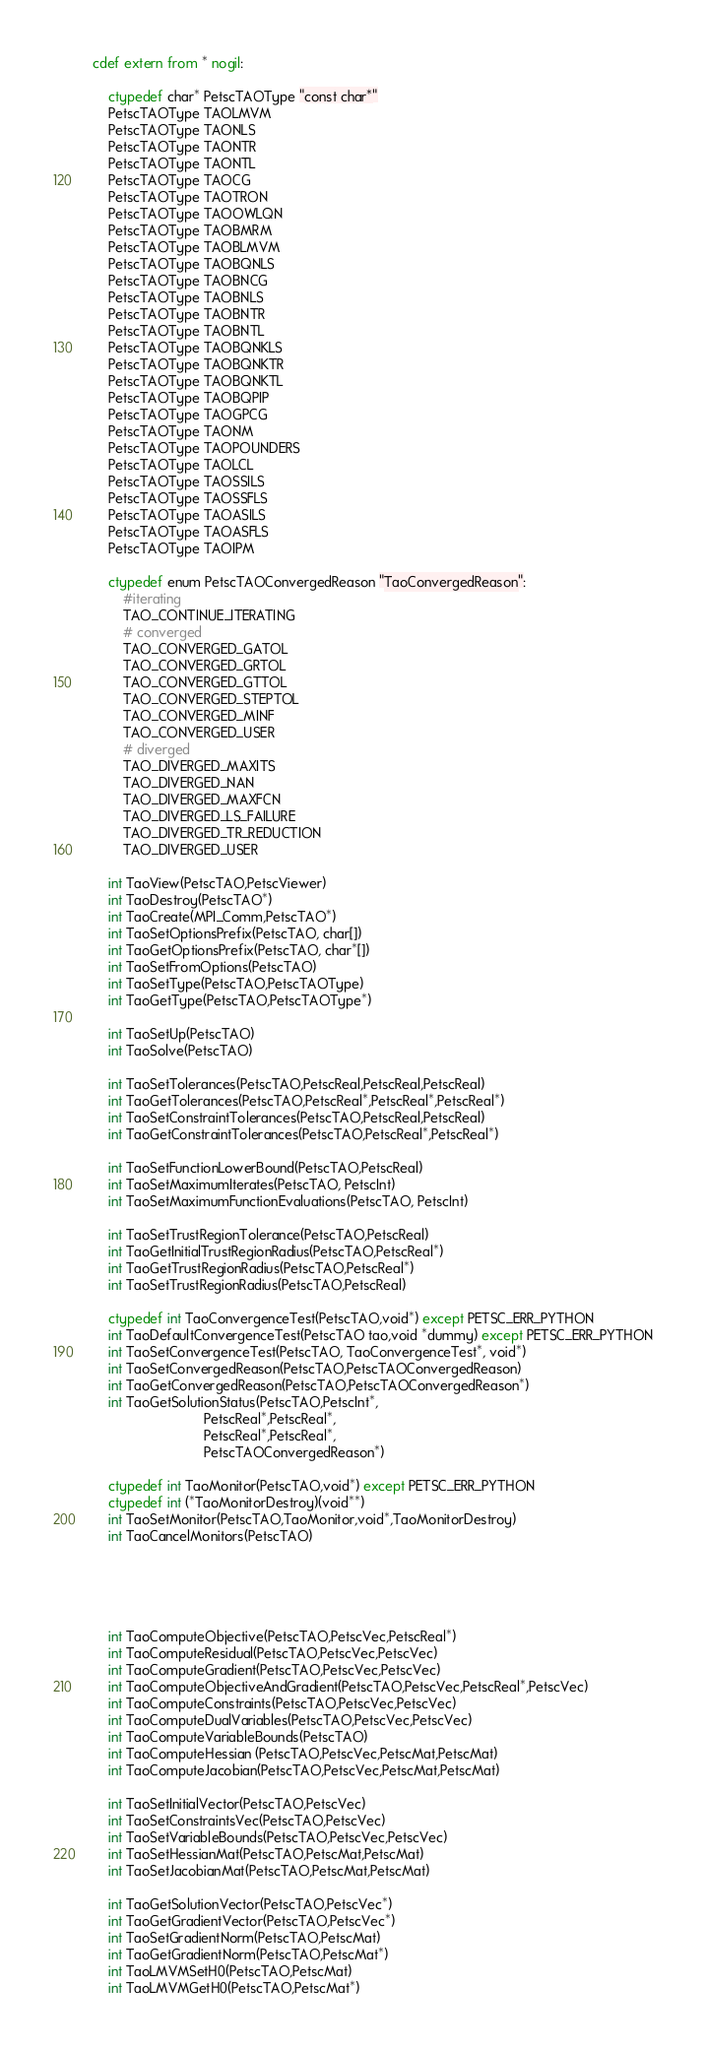<code> <loc_0><loc_0><loc_500><loc_500><_Cython_>cdef extern from * nogil:

    ctypedef char* PetscTAOType "const char*"
    PetscTAOType TAOLMVM
    PetscTAOType TAONLS
    PetscTAOType TAONTR
    PetscTAOType TAONTL
    PetscTAOType TAOCG
    PetscTAOType TAOTRON
    PetscTAOType TAOOWLQN
    PetscTAOType TAOBMRM
    PetscTAOType TAOBLMVM
    PetscTAOType TAOBQNLS
    PetscTAOType TAOBNCG
    PetscTAOType TAOBNLS
    PetscTAOType TAOBNTR
    PetscTAOType TAOBNTL
    PetscTAOType TAOBQNKLS
    PetscTAOType TAOBQNKTR
    PetscTAOType TAOBQNKTL
    PetscTAOType TAOBQPIP
    PetscTAOType TAOGPCG
    PetscTAOType TAONM
    PetscTAOType TAOPOUNDERS
    PetscTAOType TAOLCL
    PetscTAOType TAOSSILS
    PetscTAOType TAOSSFLS
    PetscTAOType TAOASILS
    PetscTAOType TAOASFLS
    PetscTAOType TAOIPM

    ctypedef enum PetscTAOConvergedReason "TaoConvergedReason":
        #iterating
        TAO_CONTINUE_ITERATING
        # converged
        TAO_CONVERGED_GATOL
        TAO_CONVERGED_GRTOL
        TAO_CONVERGED_GTTOL
        TAO_CONVERGED_STEPTOL
        TAO_CONVERGED_MINF
        TAO_CONVERGED_USER
        # diverged
        TAO_DIVERGED_MAXITS
        TAO_DIVERGED_NAN
        TAO_DIVERGED_MAXFCN
        TAO_DIVERGED_LS_FAILURE
        TAO_DIVERGED_TR_REDUCTION
        TAO_DIVERGED_USER

    int TaoView(PetscTAO,PetscViewer)
    int TaoDestroy(PetscTAO*)
    int TaoCreate(MPI_Comm,PetscTAO*)
    int TaoSetOptionsPrefix(PetscTAO, char[])
    int TaoGetOptionsPrefix(PetscTAO, char*[])
    int TaoSetFromOptions(PetscTAO)
    int TaoSetType(PetscTAO,PetscTAOType)
    int TaoGetType(PetscTAO,PetscTAOType*)

    int TaoSetUp(PetscTAO)
    int TaoSolve(PetscTAO)

    int TaoSetTolerances(PetscTAO,PetscReal,PetscReal,PetscReal)
    int TaoGetTolerances(PetscTAO,PetscReal*,PetscReal*,PetscReal*)
    int TaoSetConstraintTolerances(PetscTAO,PetscReal,PetscReal)
    int TaoGetConstraintTolerances(PetscTAO,PetscReal*,PetscReal*)

    int TaoSetFunctionLowerBound(PetscTAO,PetscReal)
    int TaoSetMaximumIterates(PetscTAO, PetscInt)
    int TaoSetMaximumFunctionEvaluations(PetscTAO, PetscInt)

    int TaoSetTrustRegionTolerance(PetscTAO,PetscReal)
    int TaoGetInitialTrustRegionRadius(PetscTAO,PetscReal*)
    int TaoGetTrustRegionRadius(PetscTAO,PetscReal*)
    int TaoSetTrustRegionRadius(PetscTAO,PetscReal)

    ctypedef int TaoConvergenceTest(PetscTAO,void*) except PETSC_ERR_PYTHON
    int TaoDefaultConvergenceTest(PetscTAO tao,void *dummy) except PETSC_ERR_PYTHON
    int TaoSetConvergenceTest(PetscTAO, TaoConvergenceTest*, void*)
    int TaoSetConvergedReason(PetscTAO,PetscTAOConvergedReason)
    int TaoGetConvergedReason(PetscTAO,PetscTAOConvergedReason*)
    int TaoGetSolutionStatus(PetscTAO,PetscInt*,
                             PetscReal*,PetscReal*,
                             PetscReal*,PetscReal*,
                             PetscTAOConvergedReason*)

    ctypedef int TaoMonitor(PetscTAO,void*) except PETSC_ERR_PYTHON
    ctypedef int (*TaoMonitorDestroy)(void**)
    int TaoSetMonitor(PetscTAO,TaoMonitor,void*,TaoMonitorDestroy)
    int TaoCancelMonitors(PetscTAO)





    int TaoComputeObjective(PetscTAO,PetscVec,PetscReal*)
    int TaoComputeResidual(PetscTAO,PetscVec,PetscVec)
    int TaoComputeGradient(PetscTAO,PetscVec,PetscVec)
    int TaoComputeObjectiveAndGradient(PetscTAO,PetscVec,PetscReal*,PetscVec)
    int TaoComputeConstraints(PetscTAO,PetscVec,PetscVec)
    int TaoComputeDualVariables(PetscTAO,PetscVec,PetscVec)
    int TaoComputeVariableBounds(PetscTAO)
    int TaoComputeHessian (PetscTAO,PetscVec,PetscMat,PetscMat)
    int TaoComputeJacobian(PetscTAO,PetscVec,PetscMat,PetscMat)

    int TaoSetInitialVector(PetscTAO,PetscVec)
    int TaoSetConstraintsVec(PetscTAO,PetscVec)
    int TaoSetVariableBounds(PetscTAO,PetscVec,PetscVec)
    int TaoSetHessianMat(PetscTAO,PetscMat,PetscMat)
    int TaoSetJacobianMat(PetscTAO,PetscMat,PetscMat)

    int TaoGetSolutionVector(PetscTAO,PetscVec*)
    int TaoGetGradientVector(PetscTAO,PetscVec*)
    int TaoSetGradientNorm(PetscTAO,PetscMat)
    int TaoGetGradientNorm(PetscTAO,PetscMat*)
    int TaoLMVMSetH0(PetscTAO,PetscMat)
    int TaoLMVMGetH0(PetscTAO,PetscMat*)</code> 